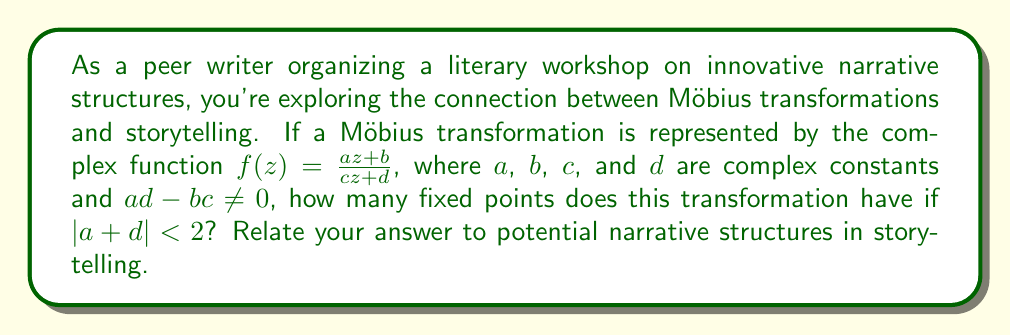Help me with this question. To solve this problem, we need to follow these steps:

1) First, recall that the fixed points of a Möbius transformation are the solutions to the equation $f(z) = z$. This gives us:

   $$\frac{az + b}{cz + d} = z$$

2) Multiply both sides by $(cz + d)$:

   $$az + b = z(cz + d)$$

3) Expand the right side:

   $$az + b = cz^2 + dz$$

4) Rearrange terms:

   $$cz^2 + (d-a)z - b = 0$$

5) This is a quadratic equation. The number of solutions (fixed points) depends on the discriminant, $\Delta = (d-a)^2 + 4bc$.

6) For a Möbius transformation, we can express the discriminant in terms of the trace of the matrix representation:

   $$\Delta = (a+d)^2 - 4(ad-bc) = (a+d)^2 - 4$$

7) Given that $|a + d| < 2$, we can conclude that $(a+d)^2 < 4$.

8) Therefore, $\Delta = (a+d)^2 - 4 < 4 - 4 = 0$

9) When the discriminant is negative, the quadratic equation has two distinct complex conjugate roots.

In terms of narrative structure, this result can be interpreted as follows:

- The two fixed points represent two stable narrative states or perspectives.
- The complex nature of these points suggests that these states are not straightforward or easily attainable in the story.
- The conjugate relationship between the points could represent a duality or mirror-like quality in the narrative structure.
- The continuous transformation between these points (as represented by the Möbius transformation) could symbolize a cyclical or spiraling narrative that never quite returns to its starting point, but continuously shifts between two interrelated states or perspectives.
Answer: The Möbius transformation has 2 distinct complex conjugate fixed points when $|a + d| < 2$. This can be related to a narrative structure that oscillates between two intertwined, non-trivial states or perspectives, creating a complex, cyclical storytelling approach. 